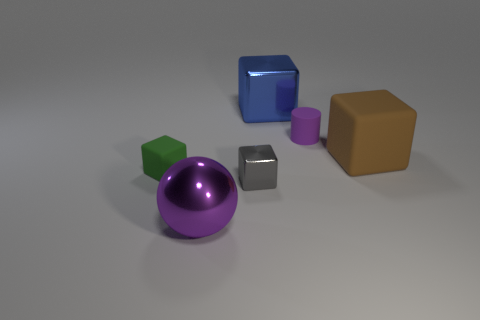Subtract all big rubber blocks. How many blocks are left? 3 Subtract 2 blocks. How many blocks are left? 2 Subtract all green blocks. How many blocks are left? 3 Add 3 big metal spheres. How many objects exist? 9 Subtract all red cubes. Subtract all cyan spheres. How many cubes are left? 4 Subtract all balls. How many objects are left? 5 Subtract all small gray shiny things. Subtract all small purple things. How many objects are left? 4 Add 2 small purple cylinders. How many small purple cylinders are left? 3 Add 3 big blue shiny things. How many big blue shiny things exist? 4 Subtract 0 yellow cubes. How many objects are left? 6 